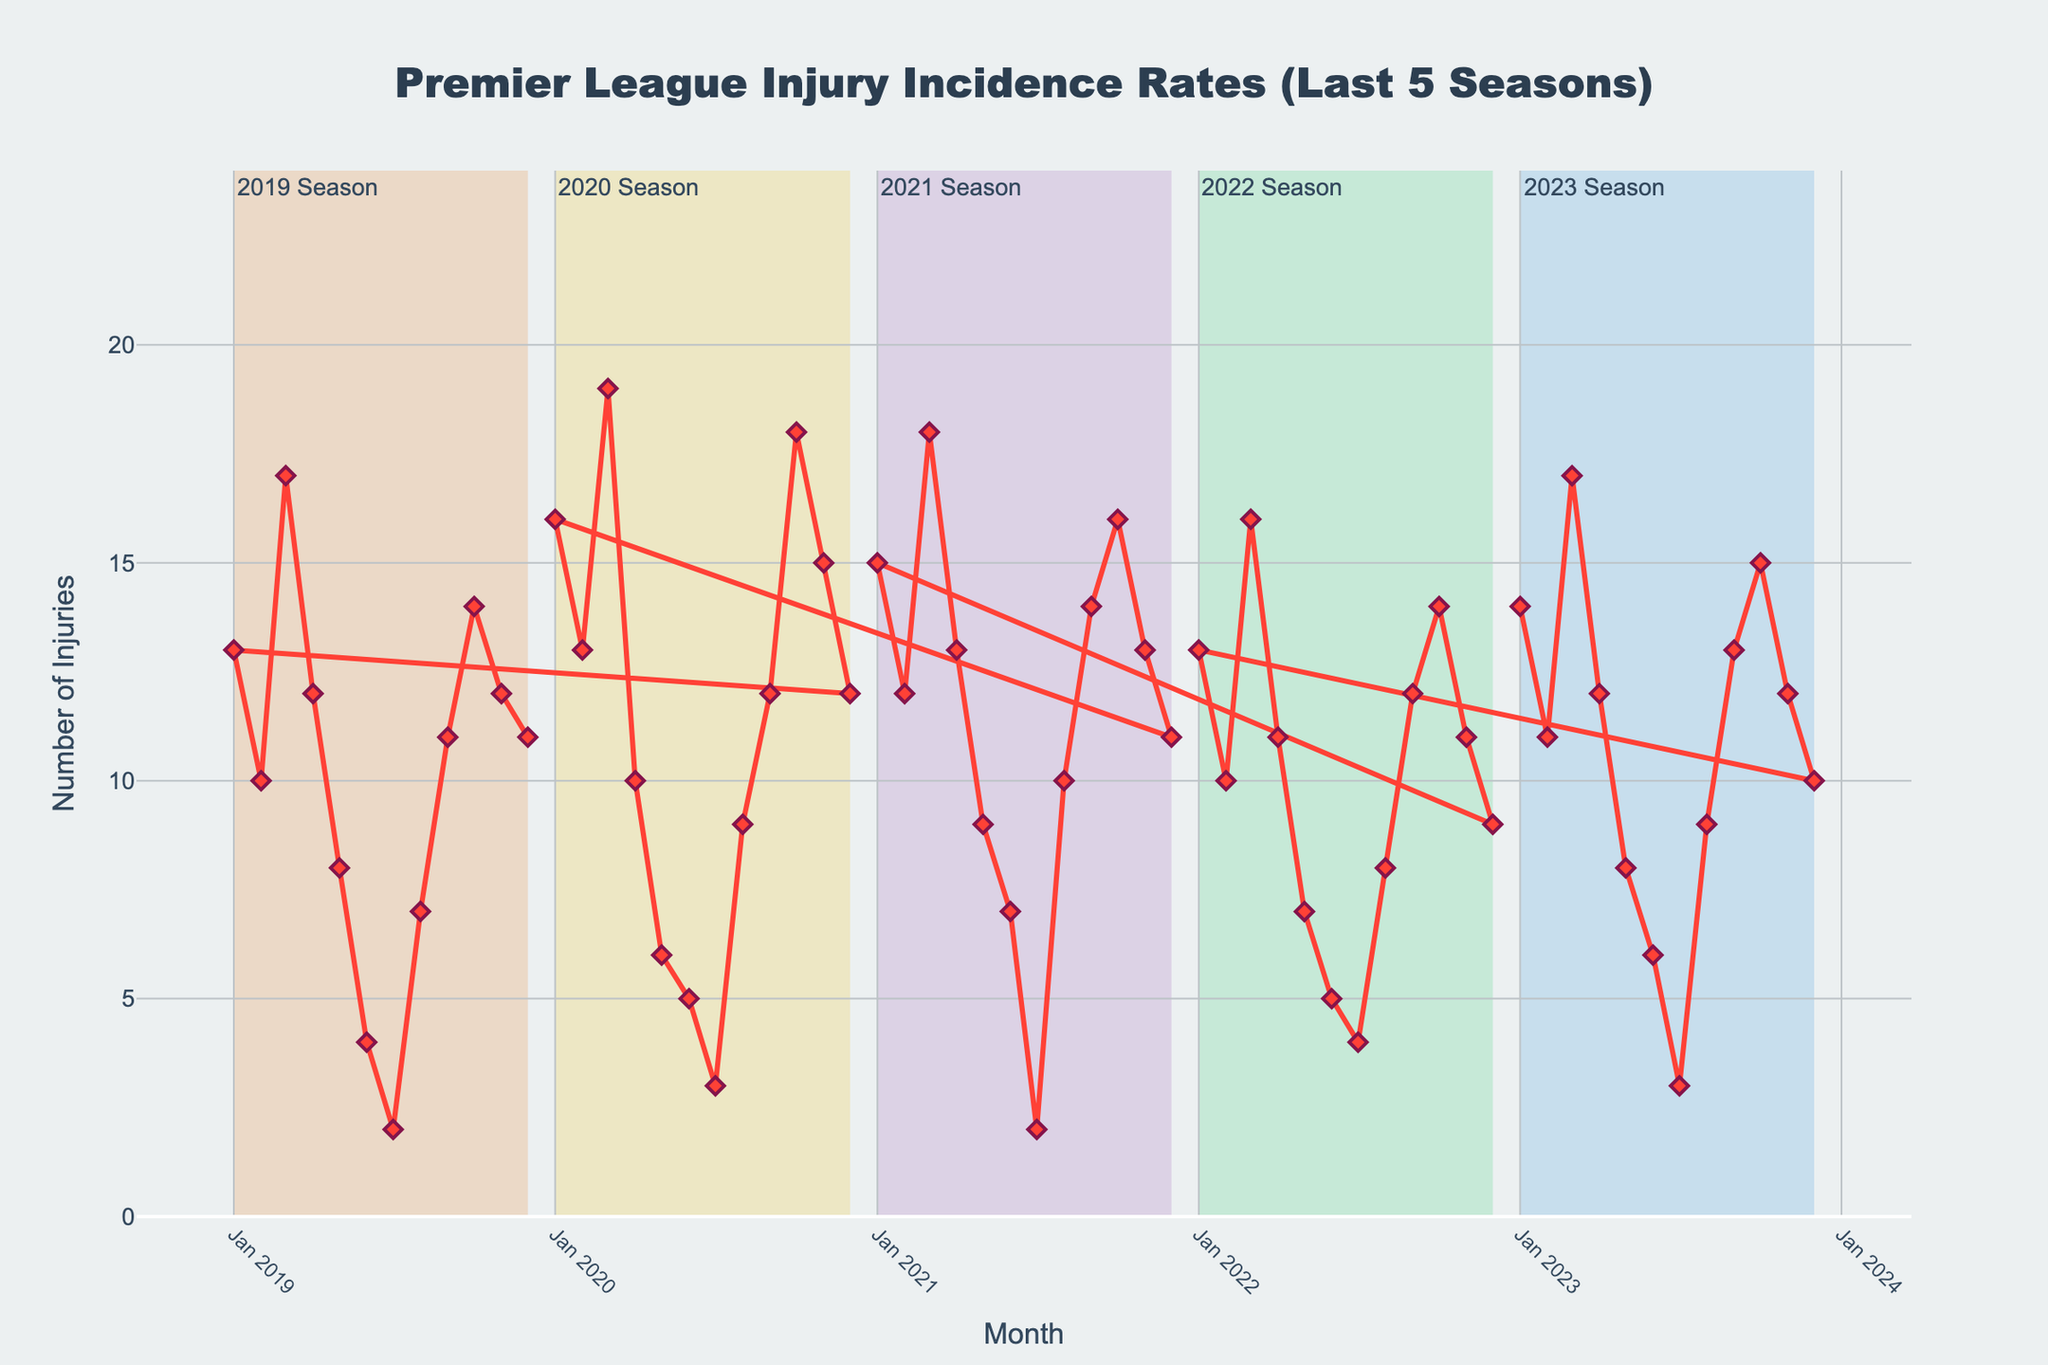What's the trend in injury incidents over the 5-year period? The trend can be observed by analyzing the time series plot. Injury incidents seem to have cyclical patterns within each year, with more injuries typically occurring in specific months, but overall there's no clear upward or downward trend across the entire 5-year period.
Answer: No clear trend Which season had the highest peak in injury incidents? By looking at the plot, we identify the highest peaks by checking the points where the line reaches its maximum value. The 2019-2020 season had the highest peak in injury incidents in March 2020, reaching 19 incidents.
Answer: 2019-2020 Are there any noticeable dips in injury incidents? Notable dips are the points where the number of injury incidents drops significantly. A noticeable dip is observed in June and July across all years, indicating a consistent lower incident rate during these months.
Answer: June and July How does the number of injuries in January 2023 compare to those in January 2022? Observing the data points corresponding to January in the respective years, January 2023 had 14 incidents, while January 2022 had 13 incidents.
Answer: Higher in 2023 What is the average number of injury incidents in March over the 5 years? To compute the average, add the number of injuries in March for each year and divide by the number of years (17+16+18+19+17)/5. So, the average is (87/5).
Answer: 17.4 Which month typically has the lowest number of injuries? Observing the pattern in the plot, July consistently shows the lowest number of injuries across the 5-year period. This can be inferred since it repeatedly shows the lowest points in the plot.
Answer: July In which year was the injury incidence in February the lowest? By comparing the values of February across all years, February 2019 and February 2022 both had 10 incidents, which are the lowest compared to other years.
Answer: 2019 and 2022 What can be inferred about injury rates during the offseason? The plot highlights the offseason periods, typically in the summer months (June to August), where we often see a marked decline in injury incidents. This indicates fewer matches and less physical strain on players.
Answer: Lower rates in offseason Do injury incidents increase or decrease as the football season progresses? Generally, the plot shows that at the start of the season, and towards the middle to end of each year, there is an increase in injury incidents, then it dips in the summer, showing a cyclical increase and decrease pattern throughout the year.
Answer: Increase then decrease How does October 2020 compare to October 2021 in terms of injury incidents? The plot shows that in October 2020, the injuries were at 18, whereas in October 2021, the injuries were 16. Comparing these, October 2020 had a higher number of incidents.
Answer: Higher in 2020 